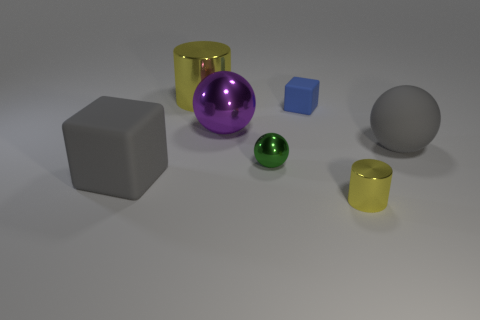What size is the matte ball that is the same color as the large block?
Your response must be concise. Large. Is the color of the small metal cylinder the same as the metallic object behind the small rubber block?
Your answer should be very brief. Yes. What number of cylinders are small yellow rubber things or green objects?
Give a very brief answer. 0. Are there any other things of the same color as the big rubber cube?
Ensure brevity in your answer.  Yes. The object left of the cylinder that is behind the tiny rubber thing is made of what material?
Provide a succinct answer. Rubber. Is the large cylinder made of the same material as the large ball on the right side of the green thing?
Ensure brevity in your answer.  No. What number of things are either rubber objects behind the big cube or large spheres?
Your answer should be very brief. 3. Is there a big metal object that has the same color as the small shiny cylinder?
Offer a very short reply. Yes. Do the purple object and the yellow metallic thing that is on the left side of the green shiny ball have the same shape?
Give a very brief answer. No. What number of large objects are both in front of the big cylinder and left of the green shiny sphere?
Provide a succinct answer. 2. 